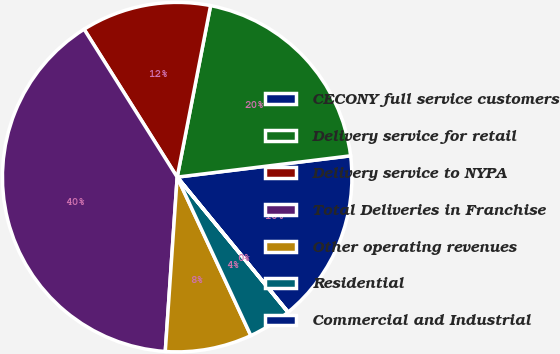Convert chart. <chart><loc_0><loc_0><loc_500><loc_500><pie_chart><fcel>CECONY full service customers<fcel>Delivery service for retail<fcel>Delivery service to NYPA<fcel>Total Deliveries in Franchise<fcel>Other operating revenues<fcel>Residential<fcel>Commercial and Industrial<nl><fcel>16.0%<fcel>19.99%<fcel>12.0%<fcel>39.97%<fcel>8.01%<fcel>4.01%<fcel>0.01%<nl></chart> 